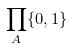<formula> <loc_0><loc_0><loc_500><loc_500>\prod _ { A } \{ 0 , 1 \}</formula> 